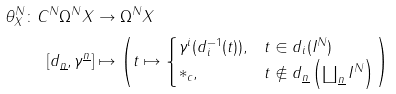Convert formula to latex. <formula><loc_0><loc_0><loc_500><loc_500>\theta ^ { N } _ { X } \colon C ^ { N } \Omega ^ { N } X & \rightarrow \Omega ^ { N } X \\ \left [ d _ { \underline { n } } , \gamma ^ { \underline { n } } \right ] & \mapsto \left ( t \mapsto \begin{cases} \gamma ^ { i } ( d _ { i } ^ { - 1 } ( t ) ) , & t \in d _ { i } ( I ^ { N } ) \\ \ast _ { c } , & t \not \in d _ { \underline { n } } \left ( \coprod _ { \underline { n } } I ^ { N } \right ) \end{cases} \right )</formula> 